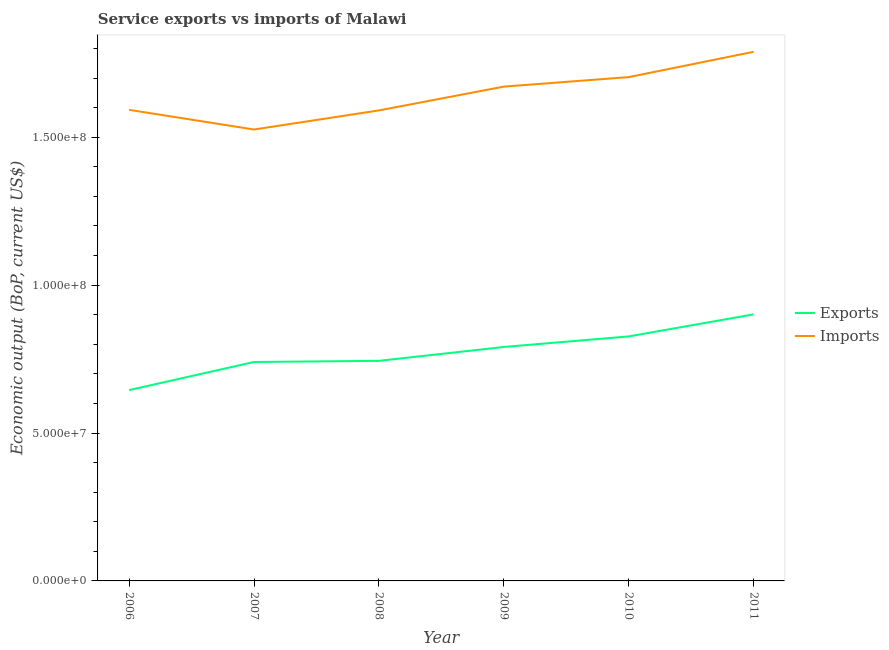How many different coloured lines are there?
Keep it short and to the point. 2. Is the number of lines equal to the number of legend labels?
Keep it short and to the point. Yes. What is the amount of service imports in 2011?
Give a very brief answer. 1.79e+08. Across all years, what is the maximum amount of service exports?
Offer a very short reply. 9.01e+07. Across all years, what is the minimum amount of service exports?
Ensure brevity in your answer.  6.45e+07. In which year was the amount of service imports maximum?
Provide a short and direct response. 2011. In which year was the amount of service imports minimum?
Offer a terse response. 2007. What is the total amount of service exports in the graph?
Offer a very short reply. 4.65e+08. What is the difference between the amount of service exports in 2006 and that in 2008?
Make the answer very short. -9.89e+06. What is the difference between the amount of service imports in 2006 and the amount of service exports in 2011?
Provide a short and direct response. 6.91e+07. What is the average amount of service exports per year?
Ensure brevity in your answer.  7.75e+07. In the year 2009, what is the difference between the amount of service imports and amount of service exports?
Provide a succinct answer. 8.80e+07. In how many years, is the amount of service exports greater than 110000000 US$?
Ensure brevity in your answer.  0. What is the ratio of the amount of service imports in 2009 to that in 2011?
Give a very brief answer. 0.93. What is the difference between the highest and the second highest amount of service exports?
Keep it short and to the point. 7.46e+06. What is the difference between the highest and the lowest amount of service exports?
Your answer should be compact. 2.56e+07. Is the sum of the amount of service imports in 2006 and 2011 greater than the maximum amount of service exports across all years?
Offer a terse response. Yes. Does the amount of service exports monotonically increase over the years?
Offer a very short reply. Yes. Is the amount of service imports strictly greater than the amount of service exports over the years?
Make the answer very short. Yes. Is the amount of service imports strictly less than the amount of service exports over the years?
Your answer should be very brief. No. How many lines are there?
Provide a short and direct response. 2. Does the graph contain any zero values?
Your response must be concise. No. What is the title of the graph?
Keep it short and to the point. Service exports vs imports of Malawi. Does "Crop" appear as one of the legend labels in the graph?
Your answer should be very brief. No. What is the label or title of the X-axis?
Offer a very short reply. Year. What is the label or title of the Y-axis?
Your response must be concise. Economic output (BoP, current US$). What is the Economic output (BoP, current US$) in Exports in 2006?
Ensure brevity in your answer.  6.45e+07. What is the Economic output (BoP, current US$) of Imports in 2006?
Your answer should be very brief. 1.59e+08. What is the Economic output (BoP, current US$) in Exports in 2007?
Offer a terse response. 7.40e+07. What is the Economic output (BoP, current US$) in Imports in 2007?
Your response must be concise. 1.53e+08. What is the Economic output (BoP, current US$) in Exports in 2008?
Provide a succinct answer. 7.44e+07. What is the Economic output (BoP, current US$) in Imports in 2008?
Offer a very short reply. 1.59e+08. What is the Economic output (BoP, current US$) in Exports in 2009?
Provide a succinct answer. 7.91e+07. What is the Economic output (BoP, current US$) in Imports in 2009?
Provide a short and direct response. 1.67e+08. What is the Economic output (BoP, current US$) of Exports in 2010?
Keep it short and to the point. 8.27e+07. What is the Economic output (BoP, current US$) of Imports in 2010?
Offer a terse response. 1.70e+08. What is the Economic output (BoP, current US$) in Exports in 2011?
Ensure brevity in your answer.  9.01e+07. What is the Economic output (BoP, current US$) of Imports in 2011?
Provide a short and direct response. 1.79e+08. Across all years, what is the maximum Economic output (BoP, current US$) in Exports?
Offer a terse response. 9.01e+07. Across all years, what is the maximum Economic output (BoP, current US$) of Imports?
Make the answer very short. 1.79e+08. Across all years, what is the minimum Economic output (BoP, current US$) of Exports?
Your answer should be very brief. 6.45e+07. Across all years, what is the minimum Economic output (BoP, current US$) of Imports?
Offer a terse response. 1.53e+08. What is the total Economic output (BoP, current US$) of Exports in the graph?
Keep it short and to the point. 4.65e+08. What is the total Economic output (BoP, current US$) of Imports in the graph?
Your answer should be compact. 9.87e+08. What is the difference between the Economic output (BoP, current US$) of Exports in 2006 and that in 2007?
Keep it short and to the point. -9.50e+06. What is the difference between the Economic output (BoP, current US$) of Imports in 2006 and that in 2007?
Make the answer very short. 6.65e+06. What is the difference between the Economic output (BoP, current US$) in Exports in 2006 and that in 2008?
Make the answer very short. -9.89e+06. What is the difference between the Economic output (BoP, current US$) of Imports in 2006 and that in 2008?
Keep it short and to the point. 1.97e+05. What is the difference between the Economic output (BoP, current US$) in Exports in 2006 and that in 2009?
Give a very brief answer. -1.46e+07. What is the difference between the Economic output (BoP, current US$) in Imports in 2006 and that in 2009?
Provide a succinct answer. -7.85e+06. What is the difference between the Economic output (BoP, current US$) of Exports in 2006 and that in 2010?
Provide a short and direct response. -1.82e+07. What is the difference between the Economic output (BoP, current US$) in Imports in 2006 and that in 2010?
Offer a terse response. -1.11e+07. What is the difference between the Economic output (BoP, current US$) of Exports in 2006 and that in 2011?
Ensure brevity in your answer.  -2.56e+07. What is the difference between the Economic output (BoP, current US$) of Imports in 2006 and that in 2011?
Your response must be concise. -1.96e+07. What is the difference between the Economic output (BoP, current US$) of Exports in 2007 and that in 2008?
Offer a terse response. -3.88e+05. What is the difference between the Economic output (BoP, current US$) of Imports in 2007 and that in 2008?
Make the answer very short. -6.45e+06. What is the difference between the Economic output (BoP, current US$) of Exports in 2007 and that in 2009?
Your response must be concise. -5.08e+06. What is the difference between the Economic output (BoP, current US$) of Imports in 2007 and that in 2009?
Your answer should be very brief. -1.45e+07. What is the difference between the Economic output (BoP, current US$) of Exports in 2007 and that in 2010?
Offer a very short reply. -8.65e+06. What is the difference between the Economic output (BoP, current US$) of Imports in 2007 and that in 2010?
Your response must be concise. -1.77e+07. What is the difference between the Economic output (BoP, current US$) in Exports in 2007 and that in 2011?
Ensure brevity in your answer.  -1.61e+07. What is the difference between the Economic output (BoP, current US$) in Imports in 2007 and that in 2011?
Your response must be concise. -2.63e+07. What is the difference between the Economic output (BoP, current US$) of Exports in 2008 and that in 2009?
Your answer should be compact. -4.69e+06. What is the difference between the Economic output (BoP, current US$) of Imports in 2008 and that in 2009?
Make the answer very short. -8.05e+06. What is the difference between the Economic output (BoP, current US$) in Exports in 2008 and that in 2010?
Your answer should be compact. -8.26e+06. What is the difference between the Economic output (BoP, current US$) in Imports in 2008 and that in 2010?
Ensure brevity in your answer.  -1.13e+07. What is the difference between the Economic output (BoP, current US$) of Exports in 2008 and that in 2011?
Keep it short and to the point. -1.57e+07. What is the difference between the Economic output (BoP, current US$) of Imports in 2008 and that in 2011?
Ensure brevity in your answer.  -1.98e+07. What is the difference between the Economic output (BoP, current US$) in Exports in 2009 and that in 2010?
Provide a succinct answer. -3.57e+06. What is the difference between the Economic output (BoP, current US$) in Imports in 2009 and that in 2010?
Offer a terse response. -3.21e+06. What is the difference between the Economic output (BoP, current US$) in Exports in 2009 and that in 2011?
Keep it short and to the point. -1.10e+07. What is the difference between the Economic output (BoP, current US$) in Imports in 2009 and that in 2011?
Provide a succinct answer. -1.18e+07. What is the difference between the Economic output (BoP, current US$) of Exports in 2010 and that in 2011?
Keep it short and to the point. -7.46e+06. What is the difference between the Economic output (BoP, current US$) of Imports in 2010 and that in 2011?
Your response must be concise. -8.56e+06. What is the difference between the Economic output (BoP, current US$) of Exports in 2006 and the Economic output (BoP, current US$) of Imports in 2007?
Make the answer very short. -8.81e+07. What is the difference between the Economic output (BoP, current US$) in Exports in 2006 and the Economic output (BoP, current US$) in Imports in 2008?
Provide a short and direct response. -9.46e+07. What is the difference between the Economic output (BoP, current US$) in Exports in 2006 and the Economic output (BoP, current US$) in Imports in 2009?
Your answer should be very brief. -1.03e+08. What is the difference between the Economic output (BoP, current US$) of Exports in 2006 and the Economic output (BoP, current US$) of Imports in 2010?
Give a very brief answer. -1.06e+08. What is the difference between the Economic output (BoP, current US$) in Exports in 2006 and the Economic output (BoP, current US$) in Imports in 2011?
Make the answer very short. -1.14e+08. What is the difference between the Economic output (BoP, current US$) in Exports in 2007 and the Economic output (BoP, current US$) in Imports in 2008?
Offer a very short reply. -8.51e+07. What is the difference between the Economic output (BoP, current US$) of Exports in 2007 and the Economic output (BoP, current US$) of Imports in 2009?
Offer a very short reply. -9.31e+07. What is the difference between the Economic output (BoP, current US$) in Exports in 2007 and the Economic output (BoP, current US$) in Imports in 2010?
Give a very brief answer. -9.63e+07. What is the difference between the Economic output (BoP, current US$) of Exports in 2007 and the Economic output (BoP, current US$) of Imports in 2011?
Provide a succinct answer. -1.05e+08. What is the difference between the Economic output (BoP, current US$) of Exports in 2008 and the Economic output (BoP, current US$) of Imports in 2009?
Make the answer very short. -9.27e+07. What is the difference between the Economic output (BoP, current US$) of Exports in 2008 and the Economic output (BoP, current US$) of Imports in 2010?
Ensure brevity in your answer.  -9.59e+07. What is the difference between the Economic output (BoP, current US$) of Exports in 2008 and the Economic output (BoP, current US$) of Imports in 2011?
Offer a terse response. -1.04e+08. What is the difference between the Economic output (BoP, current US$) of Exports in 2009 and the Economic output (BoP, current US$) of Imports in 2010?
Your response must be concise. -9.12e+07. What is the difference between the Economic output (BoP, current US$) in Exports in 2009 and the Economic output (BoP, current US$) in Imports in 2011?
Offer a very short reply. -9.98e+07. What is the difference between the Economic output (BoP, current US$) of Exports in 2010 and the Economic output (BoP, current US$) of Imports in 2011?
Offer a very short reply. -9.62e+07. What is the average Economic output (BoP, current US$) of Exports per year?
Give a very brief answer. 7.75e+07. What is the average Economic output (BoP, current US$) of Imports per year?
Give a very brief answer. 1.65e+08. In the year 2006, what is the difference between the Economic output (BoP, current US$) of Exports and Economic output (BoP, current US$) of Imports?
Provide a short and direct response. -9.47e+07. In the year 2007, what is the difference between the Economic output (BoP, current US$) of Exports and Economic output (BoP, current US$) of Imports?
Keep it short and to the point. -7.86e+07. In the year 2008, what is the difference between the Economic output (BoP, current US$) in Exports and Economic output (BoP, current US$) in Imports?
Make the answer very short. -8.47e+07. In the year 2009, what is the difference between the Economic output (BoP, current US$) in Exports and Economic output (BoP, current US$) in Imports?
Offer a terse response. -8.80e+07. In the year 2010, what is the difference between the Economic output (BoP, current US$) in Exports and Economic output (BoP, current US$) in Imports?
Give a very brief answer. -8.77e+07. In the year 2011, what is the difference between the Economic output (BoP, current US$) in Exports and Economic output (BoP, current US$) in Imports?
Offer a terse response. -8.88e+07. What is the ratio of the Economic output (BoP, current US$) of Exports in 2006 to that in 2007?
Ensure brevity in your answer.  0.87. What is the ratio of the Economic output (BoP, current US$) of Imports in 2006 to that in 2007?
Offer a very short reply. 1.04. What is the ratio of the Economic output (BoP, current US$) in Exports in 2006 to that in 2008?
Give a very brief answer. 0.87. What is the ratio of the Economic output (BoP, current US$) of Imports in 2006 to that in 2008?
Offer a very short reply. 1. What is the ratio of the Economic output (BoP, current US$) in Exports in 2006 to that in 2009?
Your response must be concise. 0.82. What is the ratio of the Economic output (BoP, current US$) in Imports in 2006 to that in 2009?
Keep it short and to the point. 0.95. What is the ratio of the Economic output (BoP, current US$) in Exports in 2006 to that in 2010?
Your answer should be very brief. 0.78. What is the ratio of the Economic output (BoP, current US$) of Imports in 2006 to that in 2010?
Give a very brief answer. 0.94. What is the ratio of the Economic output (BoP, current US$) of Exports in 2006 to that in 2011?
Give a very brief answer. 0.72. What is the ratio of the Economic output (BoP, current US$) of Imports in 2006 to that in 2011?
Your answer should be compact. 0.89. What is the ratio of the Economic output (BoP, current US$) in Imports in 2007 to that in 2008?
Keep it short and to the point. 0.96. What is the ratio of the Economic output (BoP, current US$) in Exports in 2007 to that in 2009?
Your answer should be very brief. 0.94. What is the ratio of the Economic output (BoP, current US$) of Imports in 2007 to that in 2009?
Ensure brevity in your answer.  0.91. What is the ratio of the Economic output (BoP, current US$) of Exports in 2007 to that in 2010?
Offer a very short reply. 0.9. What is the ratio of the Economic output (BoP, current US$) of Imports in 2007 to that in 2010?
Your response must be concise. 0.9. What is the ratio of the Economic output (BoP, current US$) of Exports in 2007 to that in 2011?
Offer a terse response. 0.82. What is the ratio of the Economic output (BoP, current US$) in Imports in 2007 to that in 2011?
Give a very brief answer. 0.85. What is the ratio of the Economic output (BoP, current US$) in Exports in 2008 to that in 2009?
Offer a very short reply. 0.94. What is the ratio of the Economic output (BoP, current US$) in Imports in 2008 to that in 2009?
Keep it short and to the point. 0.95. What is the ratio of the Economic output (BoP, current US$) of Imports in 2008 to that in 2010?
Your response must be concise. 0.93. What is the ratio of the Economic output (BoP, current US$) of Exports in 2008 to that in 2011?
Make the answer very short. 0.83. What is the ratio of the Economic output (BoP, current US$) of Imports in 2008 to that in 2011?
Your answer should be very brief. 0.89. What is the ratio of the Economic output (BoP, current US$) of Exports in 2009 to that in 2010?
Offer a very short reply. 0.96. What is the ratio of the Economic output (BoP, current US$) of Imports in 2009 to that in 2010?
Provide a short and direct response. 0.98. What is the ratio of the Economic output (BoP, current US$) in Exports in 2009 to that in 2011?
Your answer should be very brief. 0.88. What is the ratio of the Economic output (BoP, current US$) of Imports in 2009 to that in 2011?
Offer a terse response. 0.93. What is the ratio of the Economic output (BoP, current US$) of Exports in 2010 to that in 2011?
Keep it short and to the point. 0.92. What is the ratio of the Economic output (BoP, current US$) in Imports in 2010 to that in 2011?
Offer a very short reply. 0.95. What is the difference between the highest and the second highest Economic output (BoP, current US$) in Exports?
Give a very brief answer. 7.46e+06. What is the difference between the highest and the second highest Economic output (BoP, current US$) in Imports?
Your answer should be compact. 8.56e+06. What is the difference between the highest and the lowest Economic output (BoP, current US$) of Exports?
Your response must be concise. 2.56e+07. What is the difference between the highest and the lowest Economic output (BoP, current US$) of Imports?
Your answer should be compact. 2.63e+07. 